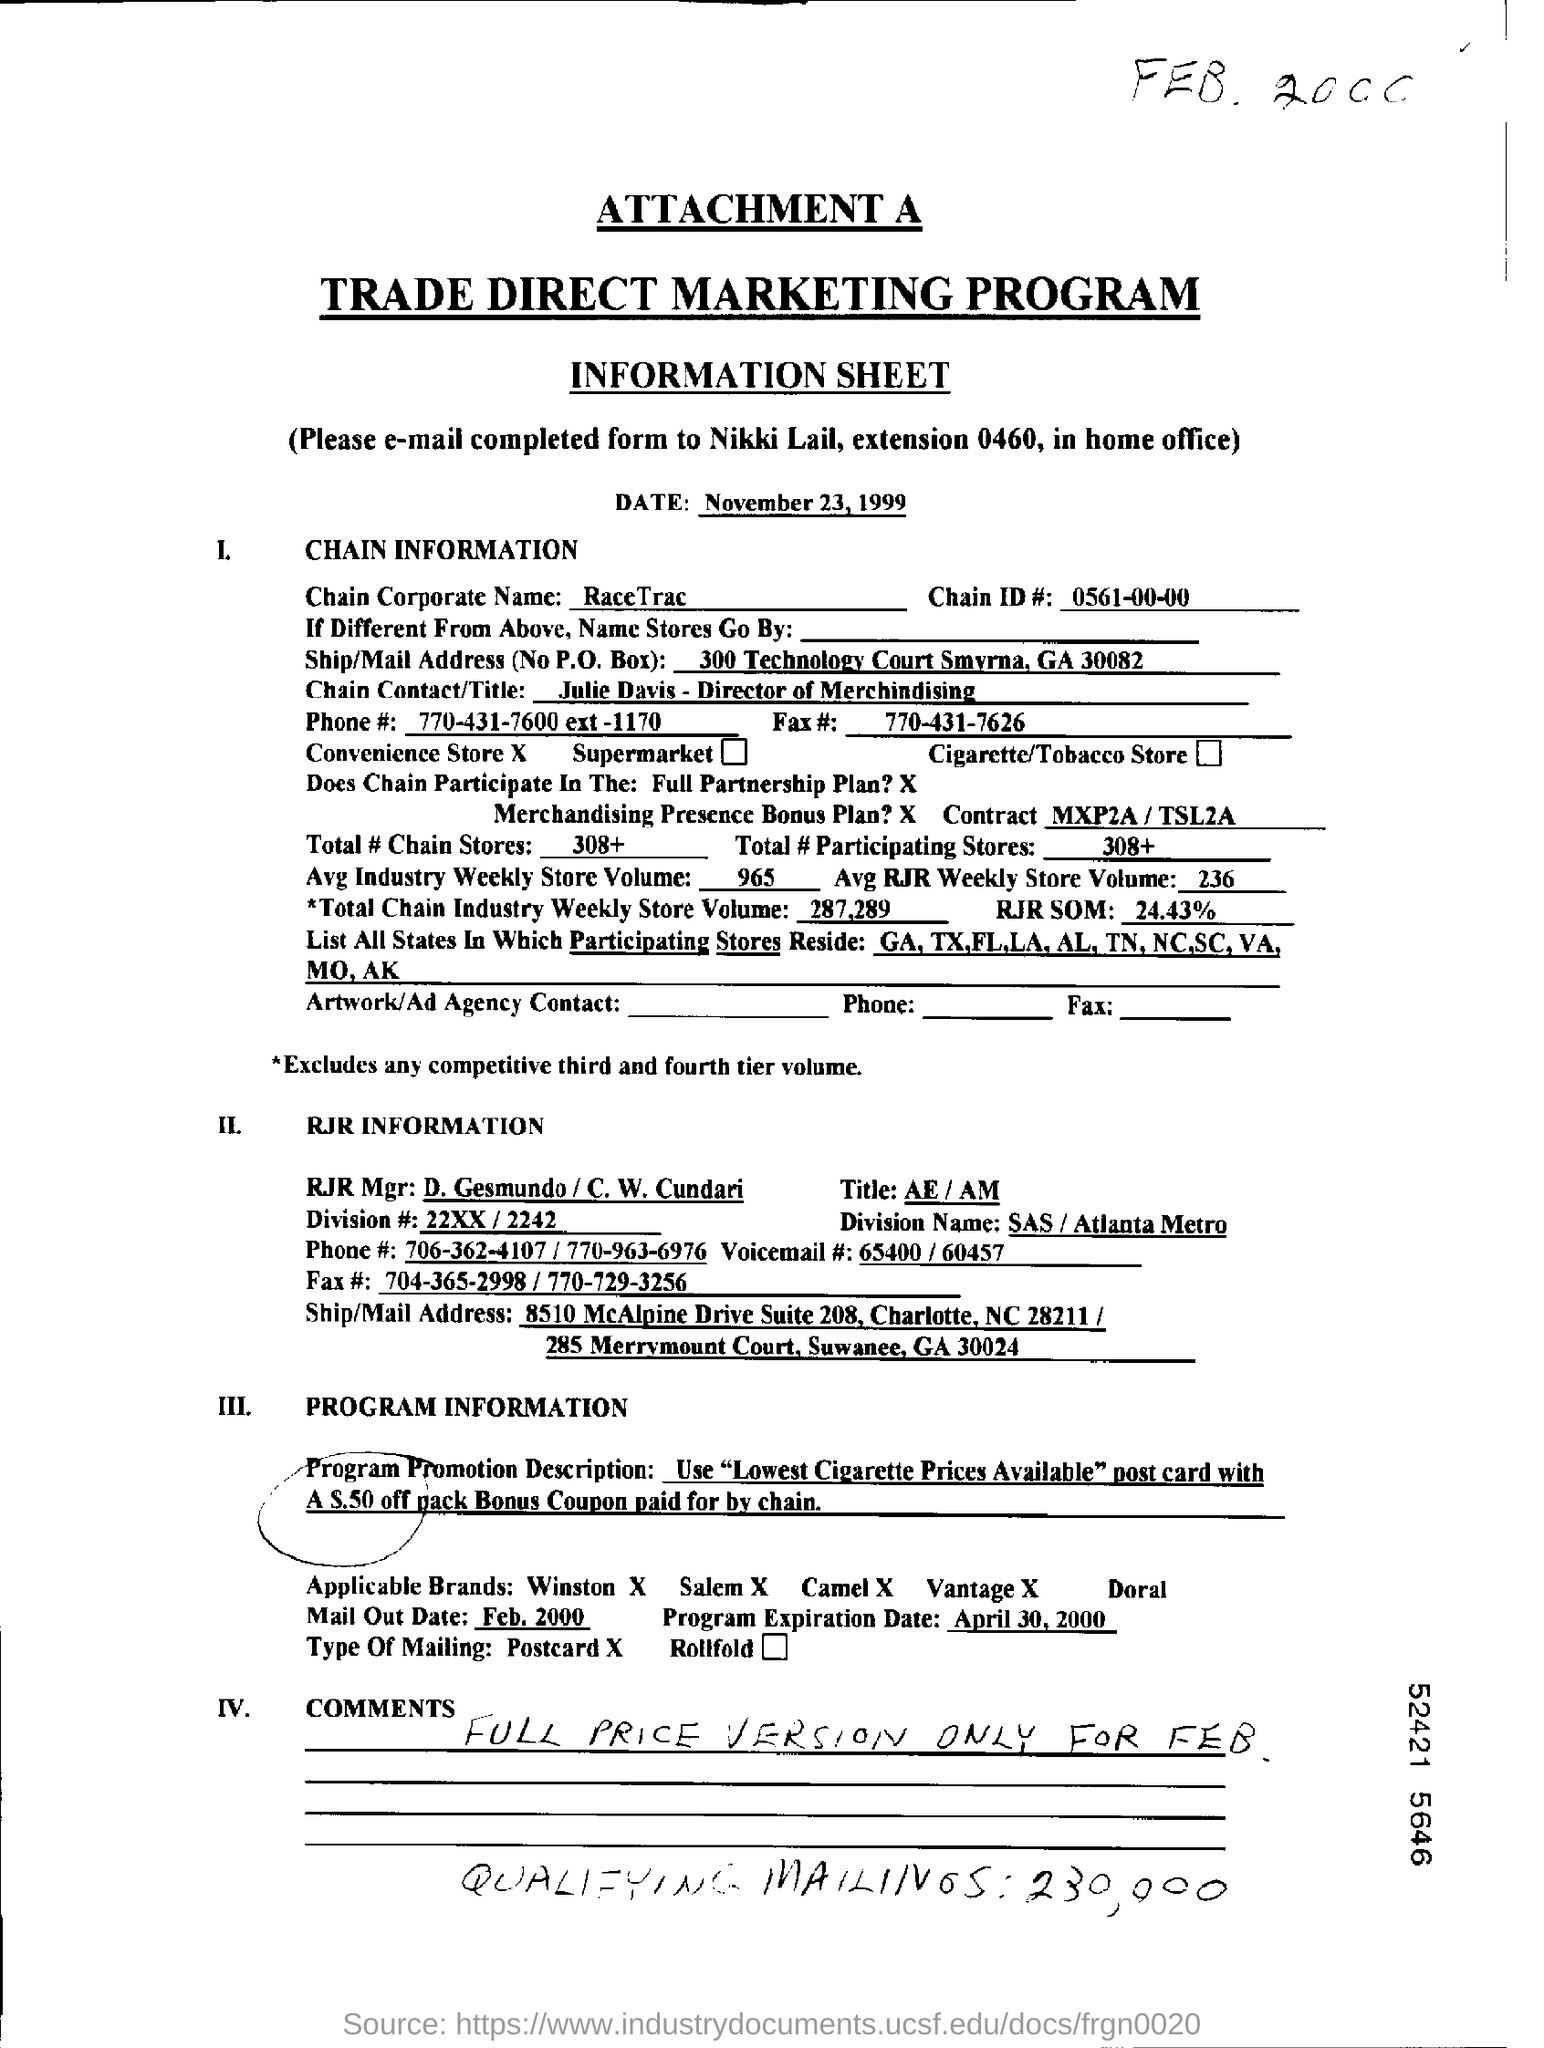When is the information sheet dated?
Offer a terse response. November 23, 1999. To whom should the completed form be e-mailed?
Keep it short and to the point. Nikki Lail. What is the chain corporate name?
Provide a succinct answer. RaceTrac. What is the chain ID No.?
Your answer should be compact. 0561-00-00. Who is the chain contact/title?
Offer a terse response. Julie Davis - Director of Merchindising. What is the total # chain stores?
Your answer should be compact. 308+. 